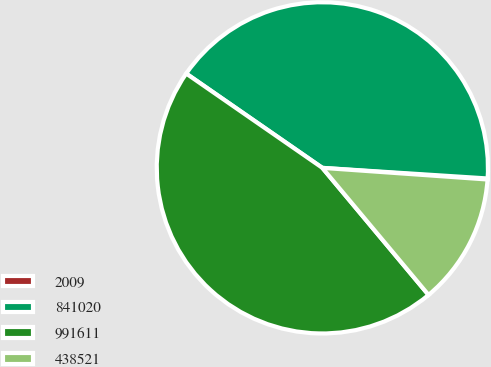Convert chart to OTSL. <chart><loc_0><loc_0><loc_500><loc_500><pie_chart><fcel>2009<fcel>841020<fcel>991611<fcel>438521<nl><fcel>0.1%<fcel>41.38%<fcel>45.72%<fcel>12.8%<nl></chart> 